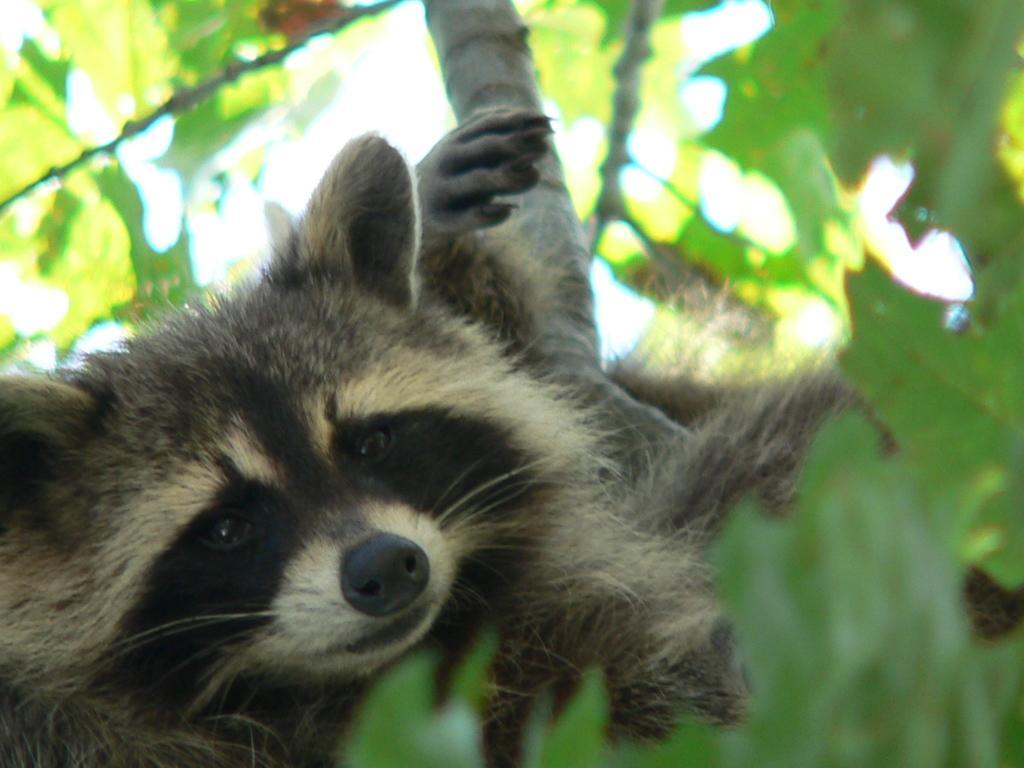Could you give a brief overview of what you see in this image? In this image there is a raccoon on a tree. 